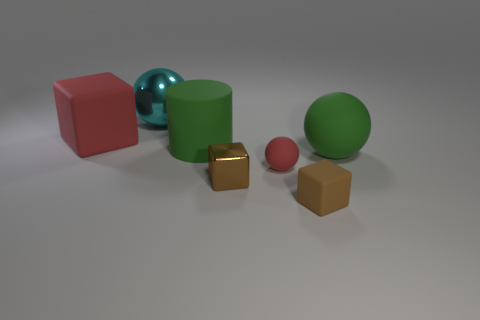How many other objects are the same shape as the small brown matte object?
Provide a short and direct response. 2. What number of green objects are spheres or small matte spheres?
Give a very brief answer. 1. Is the color of the small metallic thing that is right of the large cyan sphere the same as the small rubber cube?
Give a very brief answer. Yes. The green object that is the same material as the big green cylinder is what shape?
Your answer should be compact. Sphere. What is the color of the cube that is both in front of the big rubber cylinder and to the left of the red sphere?
Give a very brief answer. Brown. There is a brown cube that is on the right side of the shiny object that is in front of the cyan metal object; what is its size?
Your answer should be very brief. Small. Are there any small matte blocks that have the same color as the small metallic thing?
Ensure brevity in your answer.  Yes. Is the number of red cubes that are right of the tiny brown metal cube the same as the number of large yellow matte spheres?
Give a very brief answer. Yes. How many small blue metal objects are there?
Your response must be concise. 0. What is the shape of the large thing that is to the left of the large green cylinder and in front of the metal sphere?
Offer a terse response. Cube. 